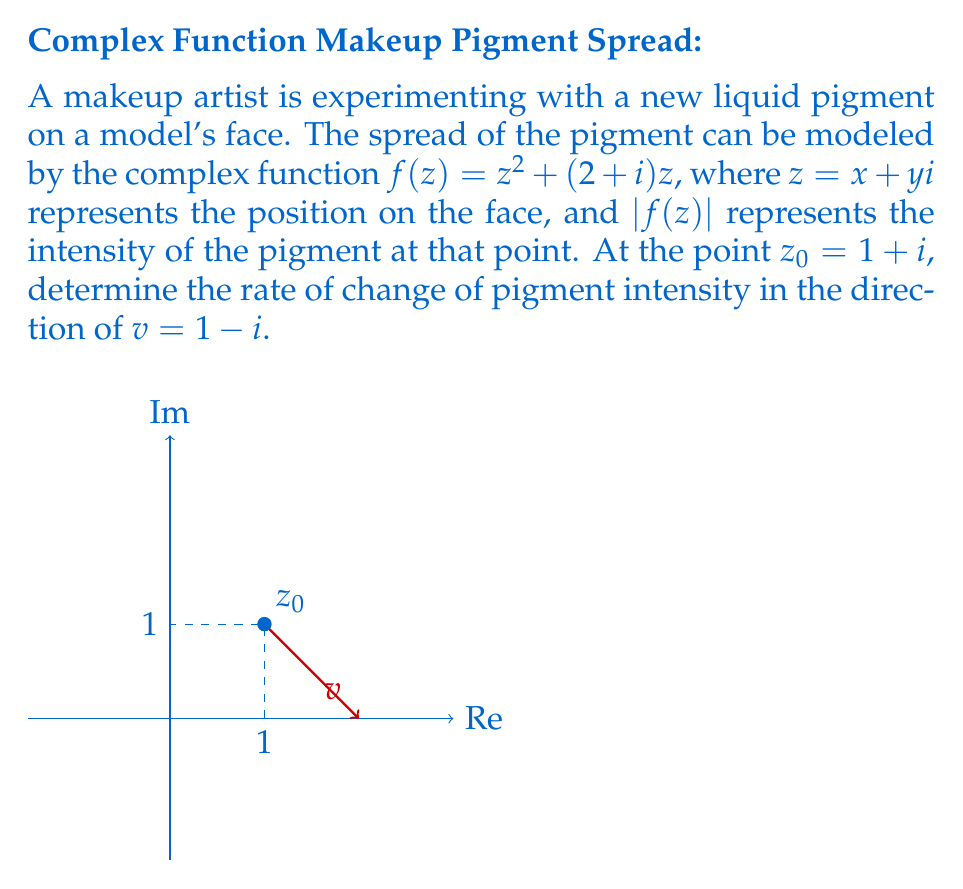Give your solution to this math problem. To solve this problem, we'll use the directional derivative formula in complex analysis:

$$\frac{\partial f}{\partial v} = \text{Re}\left(f'(z_0) \cdot \frac{v}{|v|}\right)$$

Steps:
1) First, we need to find $f'(z)$:
   $$f'(z) = \frac{d}{dz}(z^2 + (2+i)z) = 2z + (2+i)$$

2) Evaluate $f'(z_0)$:
   $$f'(1+i) = 2(1+i) + (2+i) = (4+2i) + (2+i) = 6+3i$$

3) Calculate $|v|$:
   $$|v| = |1-i| = \sqrt{1^2 + (-1)^2} = \sqrt{2}$$

4) Normalize $v$:
   $$\frac{v}{|v|} = \frac{1-i}{\sqrt{2}}$$

5) Multiply $f'(z_0)$ by the normalized $v$:
   $$(6+3i) \cdot \frac{1-i}{\sqrt{2}} = \frac{(6+3i)(1-i)}{\sqrt{2}} = \frac{6-6i+3i+3}{\sqrt{2}} = \frac{9-3i}{\sqrt{2}}$$

6) Take the real part:
   $$\text{Re}\left(\frac{9-3i}{\sqrt{2}}\right) = \frac{9}{\sqrt{2}}$$

Therefore, the rate of change of pigment intensity at $z_0 = 1+i$ in the direction of $v = 1-i$ is $\frac{9}{\sqrt{2}}$.
Answer: $\frac{9}{\sqrt{2}}$ 